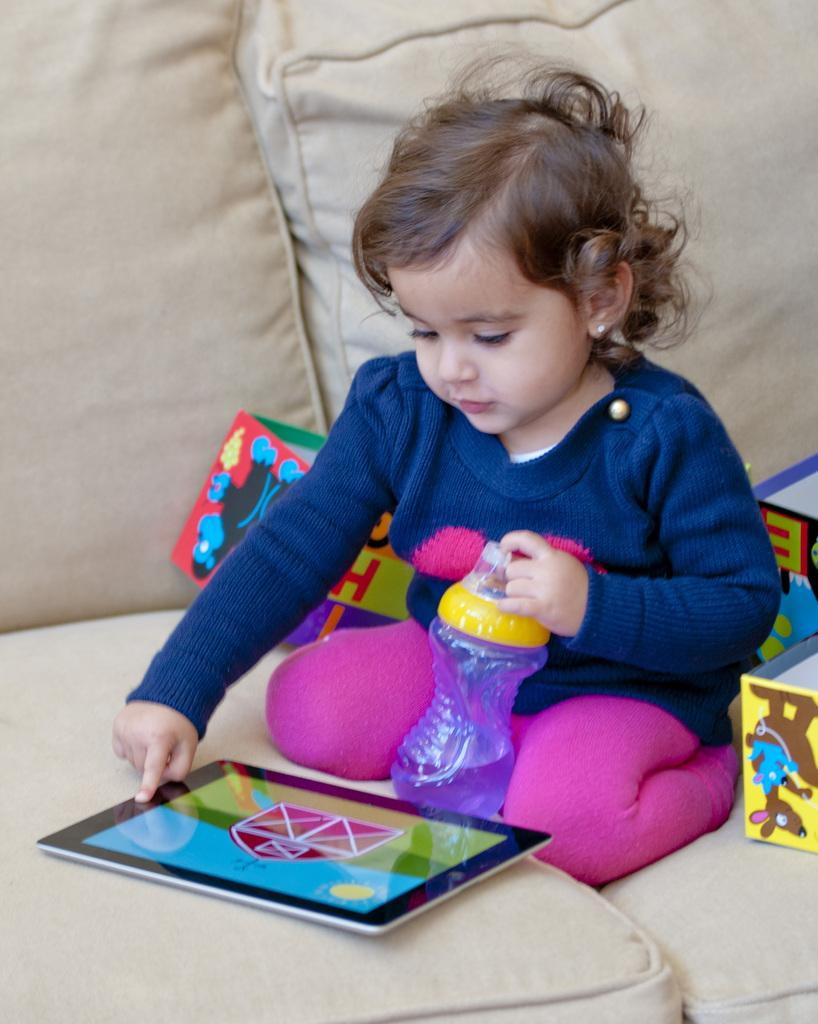What is the main subject of the image? There is a baby in the center of the image. Where is the baby sitting? The baby is sitting on a sofa. What electronic device is on the sofa? There is a tablet on the sofa. What else can be seen on the sofa besides the baby and the tablet? There are some objects on the sofa. What type of disease is the baby suffering from in the image? There is no indication of any disease in the image; the baby appears to be sitting on a sofa with a tablet and some objects. 